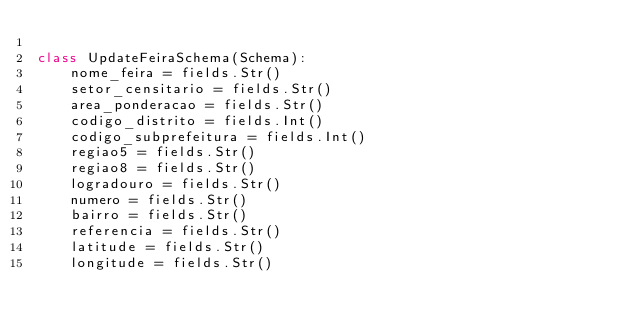<code> <loc_0><loc_0><loc_500><loc_500><_Python_>
class UpdateFeiraSchema(Schema):
    nome_feira = fields.Str()
    setor_censitario = fields.Str()
    area_ponderacao = fields.Str()
    codigo_distrito = fields.Int()
    codigo_subprefeitura = fields.Int()
    regiao5 = fields.Str()
    regiao8 = fields.Str()
    logradouro = fields.Str()
    numero = fields.Str()
    bairro = fields.Str()
    referencia = fields.Str()
    latitude = fields.Str()
    longitude = fields.Str()</code> 